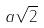Convert formula to latex. <formula><loc_0><loc_0><loc_500><loc_500>a \sqrt { 2 }</formula> 